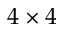<formula> <loc_0><loc_0><loc_500><loc_500>4 \times 4</formula> 